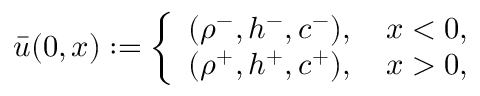Convert formula to latex. <formula><loc_0><loc_0><loc_500><loc_500>\bar { u } ( 0 , x ) \colon = \left \{ \begin{array} { l l } { ( \rho ^ { - } , h ^ { - } , c ^ { - } ) , \quad x < 0 , } \\ { ( \rho ^ { + } , h ^ { + } , c ^ { + } ) , \quad x > 0 , } \end{array}</formula> 